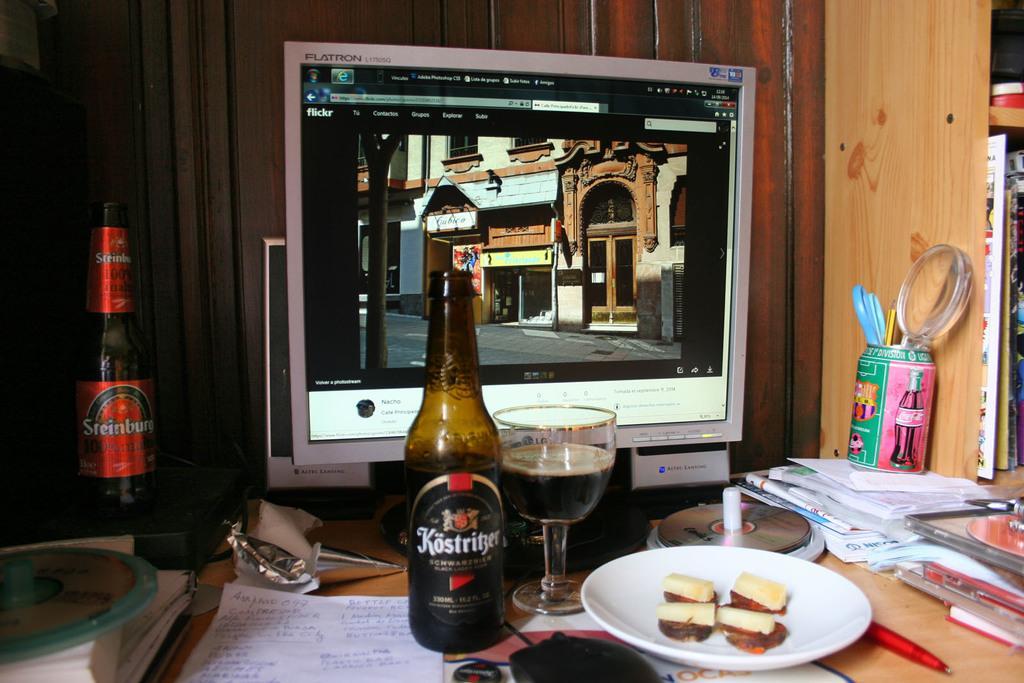In one or two sentences, can you explain what this image depicts? On this table we can able to see books, tin, monitor, glass with liquid, bottle, paper, plate with food, CD holder, papers, speaker and device. In this monitor we can able to see building. 